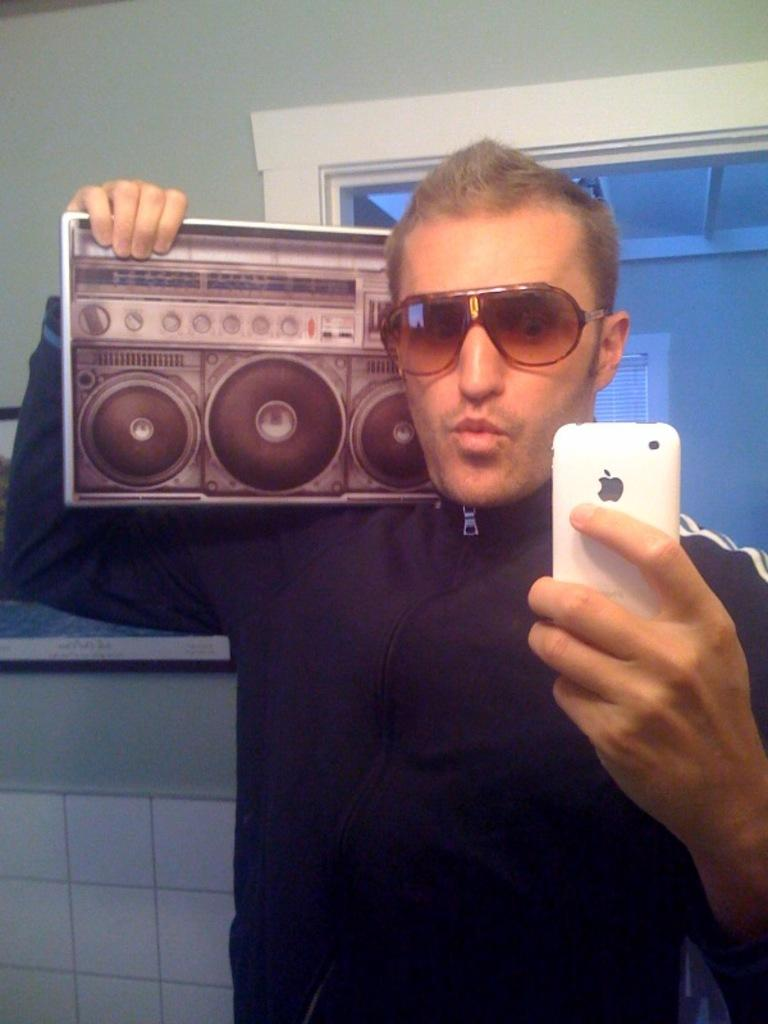What is the man in the image doing? The man is taking a picture of himself using a mirror. What objects is the man holding in the image? The man is holding a mobile in one hand and a music system in the other hand. What is the man wearing in the image? The man is wearing goggles. What type of plastic waste can be seen in the image? There is no plastic waste present in the image. What trick is the man performing in the image? The image does not depict a trick; the man is simply taking a picture of himself using a mirror. 